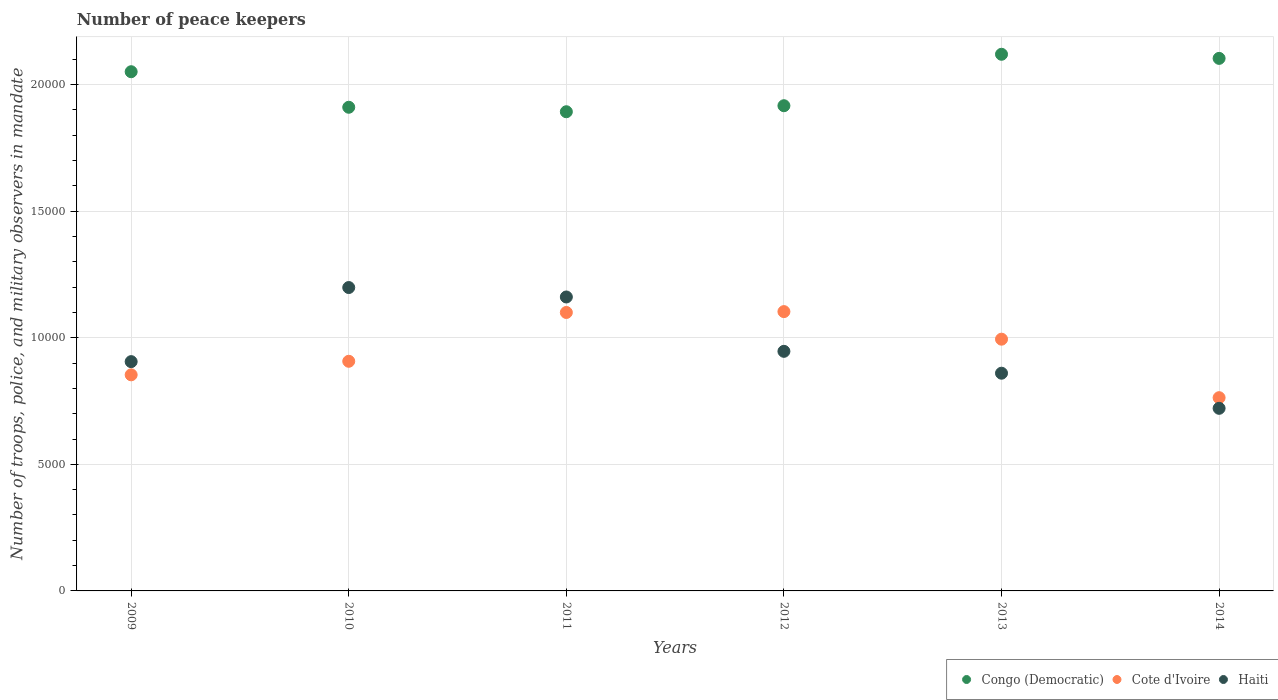What is the number of peace keepers in in Cote d'Ivoire in 2011?
Ensure brevity in your answer.  1.10e+04. Across all years, what is the maximum number of peace keepers in in Haiti?
Your answer should be compact. 1.20e+04. Across all years, what is the minimum number of peace keepers in in Haiti?
Offer a very short reply. 7213. In which year was the number of peace keepers in in Cote d'Ivoire minimum?
Offer a very short reply. 2014. What is the total number of peace keepers in in Cote d'Ivoire in the graph?
Provide a succinct answer. 5.72e+04. What is the difference between the number of peace keepers in in Haiti in 2009 and that in 2011?
Ensure brevity in your answer.  -2554. What is the difference between the number of peace keepers in in Congo (Democratic) in 2013 and the number of peace keepers in in Cote d'Ivoire in 2009?
Your response must be concise. 1.27e+04. What is the average number of peace keepers in in Congo (Democratic) per year?
Offer a very short reply. 2.00e+04. In the year 2012, what is the difference between the number of peace keepers in in Congo (Democratic) and number of peace keepers in in Haiti?
Your answer should be very brief. 9702. What is the ratio of the number of peace keepers in in Haiti in 2010 to that in 2012?
Offer a very short reply. 1.27. Is the difference between the number of peace keepers in in Congo (Democratic) in 2009 and 2013 greater than the difference between the number of peace keepers in in Haiti in 2009 and 2013?
Offer a terse response. No. What is the difference between the highest and the second highest number of peace keepers in in Cote d'Ivoire?
Your answer should be very brief. 34. What is the difference between the highest and the lowest number of peace keepers in in Congo (Democratic)?
Make the answer very short. 2270. Is the sum of the number of peace keepers in in Cote d'Ivoire in 2009 and 2010 greater than the maximum number of peace keepers in in Congo (Democratic) across all years?
Offer a very short reply. No. Is it the case that in every year, the sum of the number of peace keepers in in Haiti and number of peace keepers in in Congo (Democratic)  is greater than the number of peace keepers in in Cote d'Ivoire?
Your response must be concise. Yes. Is the number of peace keepers in in Cote d'Ivoire strictly greater than the number of peace keepers in in Congo (Democratic) over the years?
Give a very brief answer. No. Is the number of peace keepers in in Haiti strictly less than the number of peace keepers in in Congo (Democratic) over the years?
Offer a very short reply. Yes. How many dotlines are there?
Your answer should be very brief. 3. How many legend labels are there?
Your answer should be very brief. 3. How are the legend labels stacked?
Your answer should be compact. Horizontal. What is the title of the graph?
Ensure brevity in your answer.  Number of peace keepers. Does "Cameroon" appear as one of the legend labels in the graph?
Offer a terse response. No. What is the label or title of the Y-axis?
Offer a terse response. Number of troops, police, and military observers in mandate. What is the Number of troops, police, and military observers in mandate of Congo (Democratic) in 2009?
Ensure brevity in your answer.  2.05e+04. What is the Number of troops, police, and military observers in mandate of Cote d'Ivoire in 2009?
Provide a succinct answer. 8536. What is the Number of troops, police, and military observers in mandate in Haiti in 2009?
Give a very brief answer. 9057. What is the Number of troops, police, and military observers in mandate in Congo (Democratic) in 2010?
Your answer should be compact. 1.91e+04. What is the Number of troops, police, and military observers in mandate of Cote d'Ivoire in 2010?
Your response must be concise. 9071. What is the Number of troops, police, and military observers in mandate of Haiti in 2010?
Your response must be concise. 1.20e+04. What is the Number of troops, police, and military observers in mandate of Congo (Democratic) in 2011?
Make the answer very short. 1.89e+04. What is the Number of troops, police, and military observers in mandate of Cote d'Ivoire in 2011?
Your answer should be very brief. 1.10e+04. What is the Number of troops, police, and military observers in mandate of Haiti in 2011?
Keep it short and to the point. 1.16e+04. What is the Number of troops, police, and military observers in mandate in Congo (Democratic) in 2012?
Give a very brief answer. 1.92e+04. What is the Number of troops, police, and military observers in mandate in Cote d'Ivoire in 2012?
Offer a terse response. 1.10e+04. What is the Number of troops, police, and military observers in mandate of Haiti in 2012?
Provide a short and direct response. 9464. What is the Number of troops, police, and military observers in mandate of Congo (Democratic) in 2013?
Provide a short and direct response. 2.12e+04. What is the Number of troops, police, and military observers in mandate of Cote d'Ivoire in 2013?
Make the answer very short. 9944. What is the Number of troops, police, and military observers in mandate in Haiti in 2013?
Provide a short and direct response. 8600. What is the Number of troops, police, and military observers in mandate of Congo (Democratic) in 2014?
Provide a succinct answer. 2.10e+04. What is the Number of troops, police, and military observers in mandate of Cote d'Ivoire in 2014?
Provide a succinct answer. 7633. What is the Number of troops, police, and military observers in mandate in Haiti in 2014?
Give a very brief answer. 7213. Across all years, what is the maximum Number of troops, police, and military observers in mandate of Congo (Democratic)?
Offer a very short reply. 2.12e+04. Across all years, what is the maximum Number of troops, police, and military observers in mandate of Cote d'Ivoire?
Your answer should be very brief. 1.10e+04. Across all years, what is the maximum Number of troops, police, and military observers in mandate in Haiti?
Give a very brief answer. 1.20e+04. Across all years, what is the minimum Number of troops, police, and military observers in mandate in Congo (Democratic)?
Give a very brief answer. 1.89e+04. Across all years, what is the minimum Number of troops, police, and military observers in mandate in Cote d'Ivoire?
Give a very brief answer. 7633. Across all years, what is the minimum Number of troops, police, and military observers in mandate in Haiti?
Make the answer very short. 7213. What is the total Number of troops, police, and military observers in mandate in Congo (Democratic) in the graph?
Ensure brevity in your answer.  1.20e+05. What is the total Number of troops, police, and military observers in mandate in Cote d'Ivoire in the graph?
Ensure brevity in your answer.  5.72e+04. What is the total Number of troops, police, and military observers in mandate of Haiti in the graph?
Provide a succinct answer. 5.79e+04. What is the difference between the Number of troops, police, and military observers in mandate of Congo (Democratic) in 2009 and that in 2010?
Make the answer very short. 1404. What is the difference between the Number of troops, police, and military observers in mandate in Cote d'Ivoire in 2009 and that in 2010?
Provide a short and direct response. -535. What is the difference between the Number of troops, police, and military observers in mandate of Haiti in 2009 and that in 2010?
Your answer should be very brief. -2927. What is the difference between the Number of troops, police, and military observers in mandate of Congo (Democratic) in 2009 and that in 2011?
Offer a very short reply. 1581. What is the difference between the Number of troops, police, and military observers in mandate in Cote d'Ivoire in 2009 and that in 2011?
Your answer should be compact. -2463. What is the difference between the Number of troops, police, and military observers in mandate of Haiti in 2009 and that in 2011?
Your answer should be very brief. -2554. What is the difference between the Number of troops, police, and military observers in mandate in Congo (Democratic) in 2009 and that in 2012?
Provide a short and direct response. 1343. What is the difference between the Number of troops, police, and military observers in mandate of Cote d'Ivoire in 2009 and that in 2012?
Offer a terse response. -2497. What is the difference between the Number of troops, police, and military observers in mandate in Haiti in 2009 and that in 2012?
Give a very brief answer. -407. What is the difference between the Number of troops, police, and military observers in mandate in Congo (Democratic) in 2009 and that in 2013?
Keep it short and to the point. -689. What is the difference between the Number of troops, police, and military observers in mandate in Cote d'Ivoire in 2009 and that in 2013?
Offer a terse response. -1408. What is the difference between the Number of troops, police, and military observers in mandate of Haiti in 2009 and that in 2013?
Ensure brevity in your answer.  457. What is the difference between the Number of troops, police, and military observers in mandate of Congo (Democratic) in 2009 and that in 2014?
Your answer should be compact. -527. What is the difference between the Number of troops, police, and military observers in mandate in Cote d'Ivoire in 2009 and that in 2014?
Offer a terse response. 903. What is the difference between the Number of troops, police, and military observers in mandate in Haiti in 2009 and that in 2014?
Offer a very short reply. 1844. What is the difference between the Number of troops, police, and military observers in mandate of Congo (Democratic) in 2010 and that in 2011?
Make the answer very short. 177. What is the difference between the Number of troops, police, and military observers in mandate in Cote d'Ivoire in 2010 and that in 2011?
Your response must be concise. -1928. What is the difference between the Number of troops, police, and military observers in mandate of Haiti in 2010 and that in 2011?
Keep it short and to the point. 373. What is the difference between the Number of troops, police, and military observers in mandate of Congo (Democratic) in 2010 and that in 2012?
Offer a terse response. -61. What is the difference between the Number of troops, police, and military observers in mandate in Cote d'Ivoire in 2010 and that in 2012?
Make the answer very short. -1962. What is the difference between the Number of troops, police, and military observers in mandate in Haiti in 2010 and that in 2012?
Provide a succinct answer. 2520. What is the difference between the Number of troops, police, and military observers in mandate of Congo (Democratic) in 2010 and that in 2013?
Offer a terse response. -2093. What is the difference between the Number of troops, police, and military observers in mandate in Cote d'Ivoire in 2010 and that in 2013?
Your answer should be compact. -873. What is the difference between the Number of troops, police, and military observers in mandate of Haiti in 2010 and that in 2013?
Keep it short and to the point. 3384. What is the difference between the Number of troops, police, and military observers in mandate in Congo (Democratic) in 2010 and that in 2014?
Your answer should be very brief. -1931. What is the difference between the Number of troops, police, and military observers in mandate in Cote d'Ivoire in 2010 and that in 2014?
Keep it short and to the point. 1438. What is the difference between the Number of troops, police, and military observers in mandate of Haiti in 2010 and that in 2014?
Your answer should be very brief. 4771. What is the difference between the Number of troops, police, and military observers in mandate of Congo (Democratic) in 2011 and that in 2012?
Your response must be concise. -238. What is the difference between the Number of troops, police, and military observers in mandate of Cote d'Ivoire in 2011 and that in 2012?
Ensure brevity in your answer.  -34. What is the difference between the Number of troops, police, and military observers in mandate of Haiti in 2011 and that in 2012?
Ensure brevity in your answer.  2147. What is the difference between the Number of troops, police, and military observers in mandate in Congo (Democratic) in 2011 and that in 2013?
Make the answer very short. -2270. What is the difference between the Number of troops, police, and military observers in mandate of Cote d'Ivoire in 2011 and that in 2013?
Provide a succinct answer. 1055. What is the difference between the Number of troops, police, and military observers in mandate of Haiti in 2011 and that in 2013?
Your answer should be compact. 3011. What is the difference between the Number of troops, police, and military observers in mandate of Congo (Democratic) in 2011 and that in 2014?
Your answer should be very brief. -2108. What is the difference between the Number of troops, police, and military observers in mandate in Cote d'Ivoire in 2011 and that in 2014?
Offer a terse response. 3366. What is the difference between the Number of troops, police, and military observers in mandate in Haiti in 2011 and that in 2014?
Ensure brevity in your answer.  4398. What is the difference between the Number of troops, police, and military observers in mandate in Congo (Democratic) in 2012 and that in 2013?
Provide a succinct answer. -2032. What is the difference between the Number of troops, police, and military observers in mandate of Cote d'Ivoire in 2012 and that in 2013?
Give a very brief answer. 1089. What is the difference between the Number of troops, police, and military observers in mandate in Haiti in 2012 and that in 2013?
Your response must be concise. 864. What is the difference between the Number of troops, police, and military observers in mandate of Congo (Democratic) in 2012 and that in 2014?
Offer a very short reply. -1870. What is the difference between the Number of troops, police, and military observers in mandate in Cote d'Ivoire in 2012 and that in 2014?
Ensure brevity in your answer.  3400. What is the difference between the Number of troops, police, and military observers in mandate of Haiti in 2012 and that in 2014?
Ensure brevity in your answer.  2251. What is the difference between the Number of troops, police, and military observers in mandate of Congo (Democratic) in 2013 and that in 2014?
Keep it short and to the point. 162. What is the difference between the Number of troops, police, and military observers in mandate of Cote d'Ivoire in 2013 and that in 2014?
Provide a succinct answer. 2311. What is the difference between the Number of troops, police, and military observers in mandate of Haiti in 2013 and that in 2014?
Provide a succinct answer. 1387. What is the difference between the Number of troops, police, and military observers in mandate in Congo (Democratic) in 2009 and the Number of troops, police, and military observers in mandate in Cote d'Ivoire in 2010?
Your response must be concise. 1.14e+04. What is the difference between the Number of troops, police, and military observers in mandate in Congo (Democratic) in 2009 and the Number of troops, police, and military observers in mandate in Haiti in 2010?
Your answer should be very brief. 8525. What is the difference between the Number of troops, police, and military observers in mandate in Cote d'Ivoire in 2009 and the Number of troops, police, and military observers in mandate in Haiti in 2010?
Your answer should be compact. -3448. What is the difference between the Number of troops, police, and military observers in mandate in Congo (Democratic) in 2009 and the Number of troops, police, and military observers in mandate in Cote d'Ivoire in 2011?
Give a very brief answer. 9510. What is the difference between the Number of troops, police, and military observers in mandate in Congo (Democratic) in 2009 and the Number of troops, police, and military observers in mandate in Haiti in 2011?
Provide a short and direct response. 8898. What is the difference between the Number of troops, police, and military observers in mandate in Cote d'Ivoire in 2009 and the Number of troops, police, and military observers in mandate in Haiti in 2011?
Provide a succinct answer. -3075. What is the difference between the Number of troops, police, and military observers in mandate in Congo (Democratic) in 2009 and the Number of troops, police, and military observers in mandate in Cote d'Ivoire in 2012?
Your response must be concise. 9476. What is the difference between the Number of troops, police, and military observers in mandate of Congo (Democratic) in 2009 and the Number of troops, police, and military observers in mandate of Haiti in 2012?
Your answer should be very brief. 1.10e+04. What is the difference between the Number of troops, police, and military observers in mandate of Cote d'Ivoire in 2009 and the Number of troops, police, and military observers in mandate of Haiti in 2012?
Give a very brief answer. -928. What is the difference between the Number of troops, police, and military observers in mandate in Congo (Democratic) in 2009 and the Number of troops, police, and military observers in mandate in Cote d'Ivoire in 2013?
Ensure brevity in your answer.  1.06e+04. What is the difference between the Number of troops, police, and military observers in mandate in Congo (Democratic) in 2009 and the Number of troops, police, and military observers in mandate in Haiti in 2013?
Your answer should be very brief. 1.19e+04. What is the difference between the Number of troops, police, and military observers in mandate in Cote d'Ivoire in 2009 and the Number of troops, police, and military observers in mandate in Haiti in 2013?
Give a very brief answer. -64. What is the difference between the Number of troops, police, and military observers in mandate in Congo (Democratic) in 2009 and the Number of troops, police, and military observers in mandate in Cote d'Ivoire in 2014?
Ensure brevity in your answer.  1.29e+04. What is the difference between the Number of troops, police, and military observers in mandate in Congo (Democratic) in 2009 and the Number of troops, police, and military observers in mandate in Haiti in 2014?
Your answer should be very brief. 1.33e+04. What is the difference between the Number of troops, police, and military observers in mandate of Cote d'Ivoire in 2009 and the Number of troops, police, and military observers in mandate of Haiti in 2014?
Offer a terse response. 1323. What is the difference between the Number of troops, police, and military observers in mandate in Congo (Democratic) in 2010 and the Number of troops, police, and military observers in mandate in Cote d'Ivoire in 2011?
Give a very brief answer. 8106. What is the difference between the Number of troops, police, and military observers in mandate in Congo (Democratic) in 2010 and the Number of troops, police, and military observers in mandate in Haiti in 2011?
Your answer should be compact. 7494. What is the difference between the Number of troops, police, and military observers in mandate in Cote d'Ivoire in 2010 and the Number of troops, police, and military observers in mandate in Haiti in 2011?
Your answer should be very brief. -2540. What is the difference between the Number of troops, police, and military observers in mandate in Congo (Democratic) in 2010 and the Number of troops, police, and military observers in mandate in Cote d'Ivoire in 2012?
Provide a short and direct response. 8072. What is the difference between the Number of troops, police, and military observers in mandate in Congo (Democratic) in 2010 and the Number of troops, police, and military observers in mandate in Haiti in 2012?
Your response must be concise. 9641. What is the difference between the Number of troops, police, and military observers in mandate of Cote d'Ivoire in 2010 and the Number of troops, police, and military observers in mandate of Haiti in 2012?
Offer a very short reply. -393. What is the difference between the Number of troops, police, and military observers in mandate of Congo (Democratic) in 2010 and the Number of troops, police, and military observers in mandate of Cote d'Ivoire in 2013?
Provide a succinct answer. 9161. What is the difference between the Number of troops, police, and military observers in mandate in Congo (Democratic) in 2010 and the Number of troops, police, and military observers in mandate in Haiti in 2013?
Your answer should be compact. 1.05e+04. What is the difference between the Number of troops, police, and military observers in mandate in Cote d'Ivoire in 2010 and the Number of troops, police, and military observers in mandate in Haiti in 2013?
Provide a short and direct response. 471. What is the difference between the Number of troops, police, and military observers in mandate of Congo (Democratic) in 2010 and the Number of troops, police, and military observers in mandate of Cote d'Ivoire in 2014?
Your response must be concise. 1.15e+04. What is the difference between the Number of troops, police, and military observers in mandate of Congo (Democratic) in 2010 and the Number of troops, police, and military observers in mandate of Haiti in 2014?
Offer a terse response. 1.19e+04. What is the difference between the Number of troops, police, and military observers in mandate of Cote d'Ivoire in 2010 and the Number of troops, police, and military observers in mandate of Haiti in 2014?
Offer a terse response. 1858. What is the difference between the Number of troops, police, and military observers in mandate of Congo (Democratic) in 2011 and the Number of troops, police, and military observers in mandate of Cote d'Ivoire in 2012?
Provide a short and direct response. 7895. What is the difference between the Number of troops, police, and military observers in mandate of Congo (Democratic) in 2011 and the Number of troops, police, and military observers in mandate of Haiti in 2012?
Your answer should be very brief. 9464. What is the difference between the Number of troops, police, and military observers in mandate of Cote d'Ivoire in 2011 and the Number of troops, police, and military observers in mandate of Haiti in 2012?
Make the answer very short. 1535. What is the difference between the Number of troops, police, and military observers in mandate in Congo (Democratic) in 2011 and the Number of troops, police, and military observers in mandate in Cote d'Ivoire in 2013?
Provide a succinct answer. 8984. What is the difference between the Number of troops, police, and military observers in mandate of Congo (Democratic) in 2011 and the Number of troops, police, and military observers in mandate of Haiti in 2013?
Offer a terse response. 1.03e+04. What is the difference between the Number of troops, police, and military observers in mandate of Cote d'Ivoire in 2011 and the Number of troops, police, and military observers in mandate of Haiti in 2013?
Offer a very short reply. 2399. What is the difference between the Number of troops, police, and military observers in mandate in Congo (Democratic) in 2011 and the Number of troops, police, and military observers in mandate in Cote d'Ivoire in 2014?
Provide a succinct answer. 1.13e+04. What is the difference between the Number of troops, police, and military observers in mandate in Congo (Democratic) in 2011 and the Number of troops, police, and military observers in mandate in Haiti in 2014?
Your answer should be very brief. 1.17e+04. What is the difference between the Number of troops, police, and military observers in mandate of Cote d'Ivoire in 2011 and the Number of troops, police, and military observers in mandate of Haiti in 2014?
Offer a terse response. 3786. What is the difference between the Number of troops, police, and military observers in mandate in Congo (Democratic) in 2012 and the Number of troops, police, and military observers in mandate in Cote d'Ivoire in 2013?
Your answer should be very brief. 9222. What is the difference between the Number of troops, police, and military observers in mandate of Congo (Democratic) in 2012 and the Number of troops, police, and military observers in mandate of Haiti in 2013?
Offer a terse response. 1.06e+04. What is the difference between the Number of troops, police, and military observers in mandate of Cote d'Ivoire in 2012 and the Number of troops, police, and military observers in mandate of Haiti in 2013?
Offer a very short reply. 2433. What is the difference between the Number of troops, police, and military observers in mandate of Congo (Democratic) in 2012 and the Number of troops, police, and military observers in mandate of Cote d'Ivoire in 2014?
Keep it short and to the point. 1.15e+04. What is the difference between the Number of troops, police, and military observers in mandate of Congo (Democratic) in 2012 and the Number of troops, police, and military observers in mandate of Haiti in 2014?
Keep it short and to the point. 1.20e+04. What is the difference between the Number of troops, police, and military observers in mandate in Cote d'Ivoire in 2012 and the Number of troops, police, and military observers in mandate in Haiti in 2014?
Your response must be concise. 3820. What is the difference between the Number of troops, police, and military observers in mandate in Congo (Democratic) in 2013 and the Number of troops, police, and military observers in mandate in Cote d'Ivoire in 2014?
Make the answer very short. 1.36e+04. What is the difference between the Number of troops, police, and military observers in mandate in Congo (Democratic) in 2013 and the Number of troops, police, and military observers in mandate in Haiti in 2014?
Offer a terse response. 1.40e+04. What is the difference between the Number of troops, police, and military observers in mandate in Cote d'Ivoire in 2013 and the Number of troops, police, and military observers in mandate in Haiti in 2014?
Provide a short and direct response. 2731. What is the average Number of troops, police, and military observers in mandate of Congo (Democratic) per year?
Your answer should be compact. 2.00e+04. What is the average Number of troops, police, and military observers in mandate of Cote d'Ivoire per year?
Keep it short and to the point. 9536. What is the average Number of troops, police, and military observers in mandate of Haiti per year?
Offer a very short reply. 9654.83. In the year 2009, what is the difference between the Number of troops, police, and military observers in mandate of Congo (Democratic) and Number of troops, police, and military observers in mandate of Cote d'Ivoire?
Provide a succinct answer. 1.20e+04. In the year 2009, what is the difference between the Number of troops, police, and military observers in mandate of Congo (Democratic) and Number of troops, police, and military observers in mandate of Haiti?
Keep it short and to the point. 1.15e+04. In the year 2009, what is the difference between the Number of troops, police, and military observers in mandate of Cote d'Ivoire and Number of troops, police, and military observers in mandate of Haiti?
Provide a short and direct response. -521. In the year 2010, what is the difference between the Number of troops, police, and military observers in mandate of Congo (Democratic) and Number of troops, police, and military observers in mandate of Cote d'Ivoire?
Your answer should be very brief. 1.00e+04. In the year 2010, what is the difference between the Number of troops, police, and military observers in mandate in Congo (Democratic) and Number of troops, police, and military observers in mandate in Haiti?
Offer a very short reply. 7121. In the year 2010, what is the difference between the Number of troops, police, and military observers in mandate in Cote d'Ivoire and Number of troops, police, and military observers in mandate in Haiti?
Keep it short and to the point. -2913. In the year 2011, what is the difference between the Number of troops, police, and military observers in mandate in Congo (Democratic) and Number of troops, police, and military observers in mandate in Cote d'Ivoire?
Your answer should be compact. 7929. In the year 2011, what is the difference between the Number of troops, police, and military observers in mandate in Congo (Democratic) and Number of troops, police, and military observers in mandate in Haiti?
Provide a short and direct response. 7317. In the year 2011, what is the difference between the Number of troops, police, and military observers in mandate in Cote d'Ivoire and Number of troops, police, and military observers in mandate in Haiti?
Make the answer very short. -612. In the year 2012, what is the difference between the Number of troops, police, and military observers in mandate of Congo (Democratic) and Number of troops, police, and military observers in mandate of Cote d'Ivoire?
Provide a short and direct response. 8133. In the year 2012, what is the difference between the Number of troops, police, and military observers in mandate in Congo (Democratic) and Number of troops, police, and military observers in mandate in Haiti?
Your answer should be very brief. 9702. In the year 2012, what is the difference between the Number of troops, police, and military observers in mandate of Cote d'Ivoire and Number of troops, police, and military observers in mandate of Haiti?
Your answer should be compact. 1569. In the year 2013, what is the difference between the Number of troops, police, and military observers in mandate in Congo (Democratic) and Number of troops, police, and military observers in mandate in Cote d'Ivoire?
Your answer should be compact. 1.13e+04. In the year 2013, what is the difference between the Number of troops, police, and military observers in mandate of Congo (Democratic) and Number of troops, police, and military observers in mandate of Haiti?
Make the answer very short. 1.26e+04. In the year 2013, what is the difference between the Number of troops, police, and military observers in mandate in Cote d'Ivoire and Number of troops, police, and military observers in mandate in Haiti?
Provide a short and direct response. 1344. In the year 2014, what is the difference between the Number of troops, police, and military observers in mandate in Congo (Democratic) and Number of troops, police, and military observers in mandate in Cote d'Ivoire?
Your answer should be very brief. 1.34e+04. In the year 2014, what is the difference between the Number of troops, police, and military observers in mandate in Congo (Democratic) and Number of troops, police, and military observers in mandate in Haiti?
Provide a succinct answer. 1.38e+04. In the year 2014, what is the difference between the Number of troops, police, and military observers in mandate of Cote d'Ivoire and Number of troops, police, and military observers in mandate of Haiti?
Ensure brevity in your answer.  420. What is the ratio of the Number of troops, police, and military observers in mandate in Congo (Democratic) in 2009 to that in 2010?
Offer a very short reply. 1.07. What is the ratio of the Number of troops, police, and military observers in mandate in Cote d'Ivoire in 2009 to that in 2010?
Offer a terse response. 0.94. What is the ratio of the Number of troops, police, and military observers in mandate of Haiti in 2009 to that in 2010?
Your answer should be compact. 0.76. What is the ratio of the Number of troops, police, and military observers in mandate in Congo (Democratic) in 2009 to that in 2011?
Your answer should be compact. 1.08. What is the ratio of the Number of troops, police, and military observers in mandate of Cote d'Ivoire in 2009 to that in 2011?
Your answer should be very brief. 0.78. What is the ratio of the Number of troops, police, and military observers in mandate in Haiti in 2009 to that in 2011?
Offer a terse response. 0.78. What is the ratio of the Number of troops, police, and military observers in mandate in Congo (Democratic) in 2009 to that in 2012?
Ensure brevity in your answer.  1.07. What is the ratio of the Number of troops, police, and military observers in mandate in Cote d'Ivoire in 2009 to that in 2012?
Keep it short and to the point. 0.77. What is the ratio of the Number of troops, police, and military observers in mandate in Haiti in 2009 to that in 2012?
Provide a short and direct response. 0.96. What is the ratio of the Number of troops, police, and military observers in mandate of Congo (Democratic) in 2009 to that in 2013?
Give a very brief answer. 0.97. What is the ratio of the Number of troops, police, and military observers in mandate in Cote d'Ivoire in 2009 to that in 2013?
Your response must be concise. 0.86. What is the ratio of the Number of troops, police, and military observers in mandate in Haiti in 2009 to that in 2013?
Provide a succinct answer. 1.05. What is the ratio of the Number of troops, police, and military observers in mandate in Congo (Democratic) in 2009 to that in 2014?
Your answer should be compact. 0.97. What is the ratio of the Number of troops, police, and military observers in mandate in Cote d'Ivoire in 2009 to that in 2014?
Make the answer very short. 1.12. What is the ratio of the Number of troops, police, and military observers in mandate of Haiti in 2009 to that in 2014?
Offer a very short reply. 1.26. What is the ratio of the Number of troops, police, and military observers in mandate of Congo (Democratic) in 2010 to that in 2011?
Make the answer very short. 1.01. What is the ratio of the Number of troops, police, and military observers in mandate in Cote d'Ivoire in 2010 to that in 2011?
Make the answer very short. 0.82. What is the ratio of the Number of troops, police, and military observers in mandate in Haiti in 2010 to that in 2011?
Keep it short and to the point. 1.03. What is the ratio of the Number of troops, police, and military observers in mandate of Congo (Democratic) in 2010 to that in 2012?
Ensure brevity in your answer.  1. What is the ratio of the Number of troops, police, and military observers in mandate of Cote d'Ivoire in 2010 to that in 2012?
Provide a short and direct response. 0.82. What is the ratio of the Number of troops, police, and military observers in mandate of Haiti in 2010 to that in 2012?
Keep it short and to the point. 1.27. What is the ratio of the Number of troops, police, and military observers in mandate of Congo (Democratic) in 2010 to that in 2013?
Your answer should be compact. 0.9. What is the ratio of the Number of troops, police, and military observers in mandate of Cote d'Ivoire in 2010 to that in 2013?
Provide a succinct answer. 0.91. What is the ratio of the Number of troops, police, and military observers in mandate of Haiti in 2010 to that in 2013?
Give a very brief answer. 1.39. What is the ratio of the Number of troops, police, and military observers in mandate in Congo (Democratic) in 2010 to that in 2014?
Offer a very short reply. 0.91. What is the ratio of the Number of troops, police, and military observers in mandate of Cote d'Ivoire in 2010 to that in 2014?
Your answer should be compact. 1.19. What is the ratio of the Number of troops, police, and military observers in mandate in Haiti in 2010 to that in 2014?
Your answer should be very brief. 1.66. What is the ratio of the Number of troops, police, and military observers in mandate in Congo (Democratic) in 2011 to that in 2012?
Offer a terse response. 0.99. What is the ratio of the Number of troops, police, and military observers in mandate in Cote d'Ivoire in 2011 to that in 2012?
Offer a terse response. 1. What is the ratio of the Number of troops, police, and military observers in mandate of Haiti in 2011 to that in 2012?
Provide a short and direct response. 1.23. What is the ratio of the Number of troops, police, and military observers in mandate in Congo (Democratic) in 2011 to that in 2013?
Ensure brevity in your answer.  0.89. What is the ratio of the Number of troops, police, and military observers in mandate of Cote d'Ivoire in 2011 to that in 2013?
Provide a succinct answer. 1.11. What is the ratio of the Number of troops, police, and military observers in mandate in Haiti in 2011 to that in 2013?
Give a very brief answer. 1.35. What is the ratio of the Number of troops, police, and military observers in mandate in Congo (Democratic) in 2011 to that in 2014?
Make the answer very short. 0.9. What is the ratio of the Number of troops, police, and military observers in mandate of Cote d'Ivoire in 2011 to that in 2014?
Your answer should be compact. 1.44. What is the ratio of the Number of troops, police, and military observers in mandate of Haiti in 2011 to that in 2014?
Provide a short and direct response. 1.61. What is the ratio of the Number of troops, police, and military observers in mandate in Congo (Democratic) in 2012 to that in 2013?
Offer a terse response. 0.9. What is the ratio of the Number of troops, police, and military observers in mandate of Cote d'Ivoire in 2012 to that in 2013?
Ensure brevity in your answer.  1.11. What is the ratio of the Number of troops, police, and military observers in mandate in Haiti in 2012 to that in 2013?
Your answer should be very brief. 1.1. What is the ratio of the Number of troops, police, and military observers in mandate in Congo (Democratic) in 2012 to that in 2014?
Your answer should be compact. 0.91. What is the ratio of the Number of troops, police, and military observers in mandate in Cote d'Ivoire in 2012 to that in 2014?
Provide a short and direct response. 1.45. What is the ratio of the Number of troops, police, and military observers in mandate in Haiti in 2012 to that in 2014?
Give a very brief answer. 1.31. What is the ratio of the Number of troops, police, and military observers in mandate of Congo (Democratic) in 2013 to that in 2014?
Your answer should be very brief. 1.01. What is the ratio of the Number of troops, police, and military observers in mandate of Cote d'Ivoire in 2013 to that in 2014?
Your answer should be very brief. 1.3. What is the ratio of the Number of troops, police, and military observers in mandate in Haiti in 2013 to that in 2014?
Provide a succinct answer. 1.19. What is the difference between the highest and the second highest Number of troops, police, and military observers in mandate in Congo (Democratic)?
Give a very brief answer. 162. What is the difference between the highest and the second highest Number of troops, police, and military observers in mandate of Haiti?
Offer a terse response. 373. What is the difference between the highest and the lowest Number of troops, police, and military observers in mandate in Congo (Democratic)?
Offer a terse response. 2270. What is the difference between the highest and the lowest Number of troops, police, and military observers in mandate in Cote d'Ivoire?
Give a very brief answer. 3400. What is the difference between the highest and the lowest Number of troops, police, and military observers in mandate of Haiti?
Your answer should be compact. 4771. 